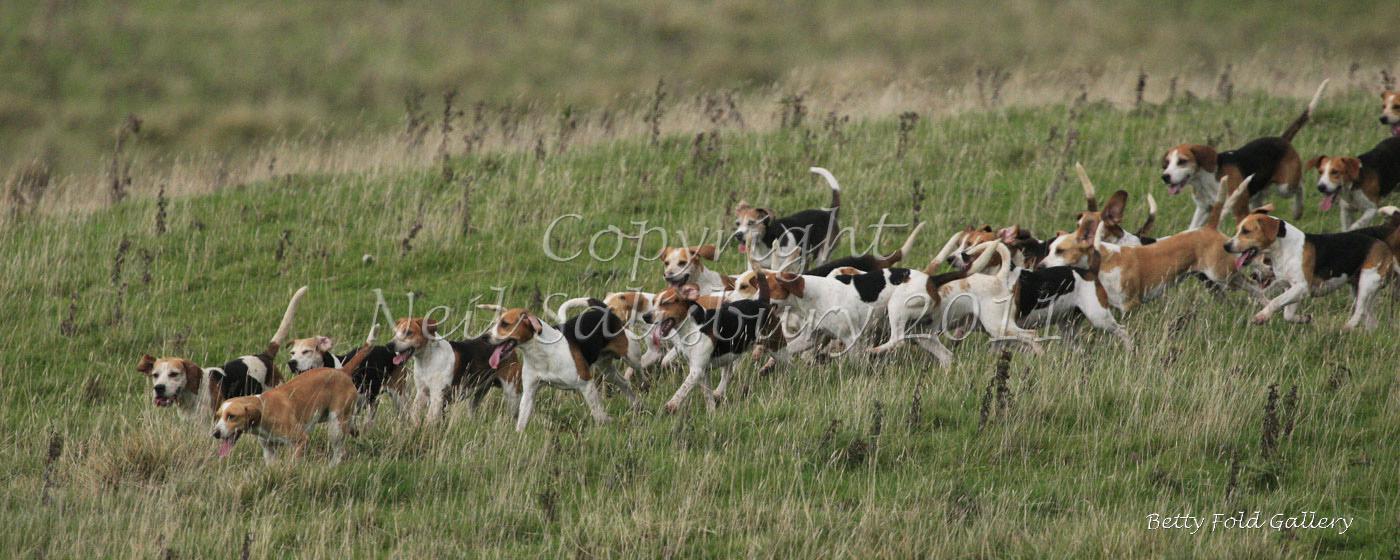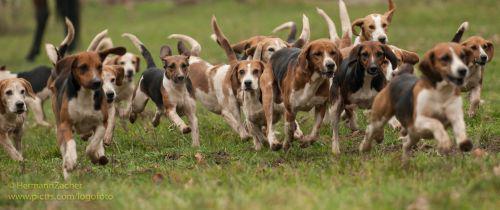The first image is the image on the left, the second image is the image on the right. Considering the images on both sides, is "Right image shows a pack of dogs running forward." valid? Answer yes or no. Yes. 